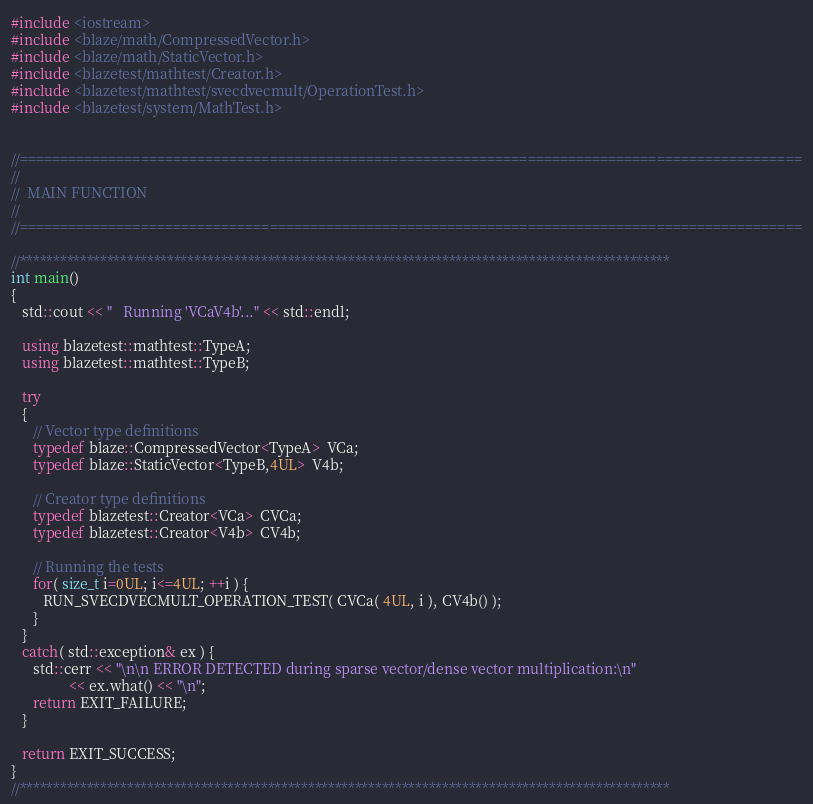<code> <loc_0><loc_0><loc_500><loc_500><_C++_>#include <iostream>
#include <blaze/math/CompressedVector.h>
#include <blaze/math/StaticVector.h>
#include <blazetest/mathtest/Creator.h>
#include <blazetest/mathtest/svecdvecmult/OperationTest.h>
#include <blazetest/system/MathTest.h>


//=================================================================================================
//
//  MAIN FUNCTION
//
//=================================================================================================

//*************************************************************************************************
int main()
{
   std::cout << "   Running 'VCaV4b'..." << std::endl;

   using blazetest::mathtest::TypeA;
   using blazetest::mathtest::TypeB;

   try
   {
      // Vector type definitions
      typedef blaze::CompressedVector<TypeA>  VCa;
      typedef blaze::StaticVector<TypeB,4UL>  V4b;

      // Creator type definitions
      typedef blazetest::Creator<VCa>  CVCa;
      typedef blazetest::Creator<V4b>  CV4b;

      // Running the tests
      for( size_t i=0UL; i<=4UL; ++i ) {
         RUN_SVECDVECMULT_OPERATION_TEST( CVCa( 4UL, i ), CV4b() );
      }
   }
   catch( std::exception& ex ) {
      std::cerr << "\n\n ERROR DETECTED during sparse vector/dense vector multiplication:\n"
                << ex.what() << "\n";
      return EXIT_FAILURE;
   }

   return EXIT_SUCCESS;
}
//*************************************************************************************************
</code> 